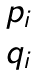Convert formula to latex. <formula><loc_0><loc_0><loc_500><loc_500>\begin{matrix} p _ { i } \\ q _ { i } \end{matrix}</formula> 